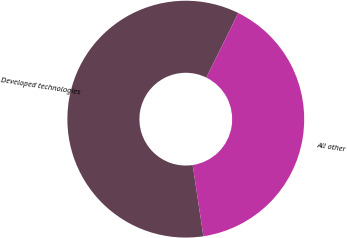Convert chart. <chart><loc_0><loc_0><loc_500><loc_500><pie_chart><fcel>Developed technologies<fcel>All other<nl><fcel>59.68%<fcel>40.32%<nl></chart> 